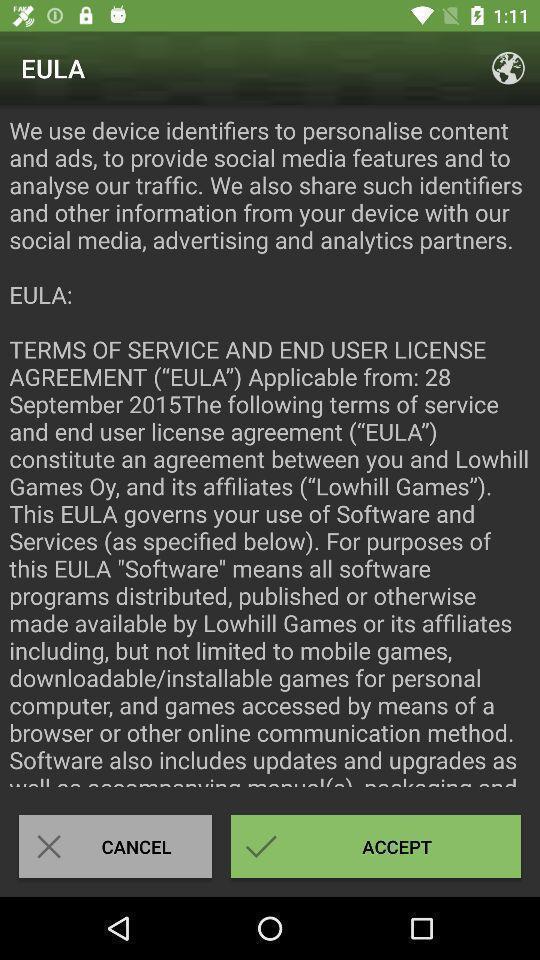Describe the visual elements of this screenshot. Permissions page of a minecraft application. 